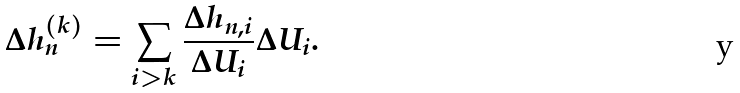Convert formula to latex. <formula><loc_0><loc_0><loc_500><loc_500>\Delta h _ { n } ^ { ( k ) } = \sum _ { i > k } \frac { \Delta h _ { n , i } } { \Delta U _ { i } } \Delta U _ { i } .</formula> 